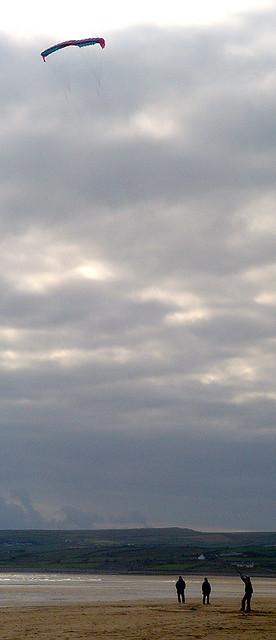Is it likely to rain?
Write a very short answer. Yes. How many ocean waves are in this photo?
Be succinct. 1. How many people are in this picture?
Quick response, please. 3. 